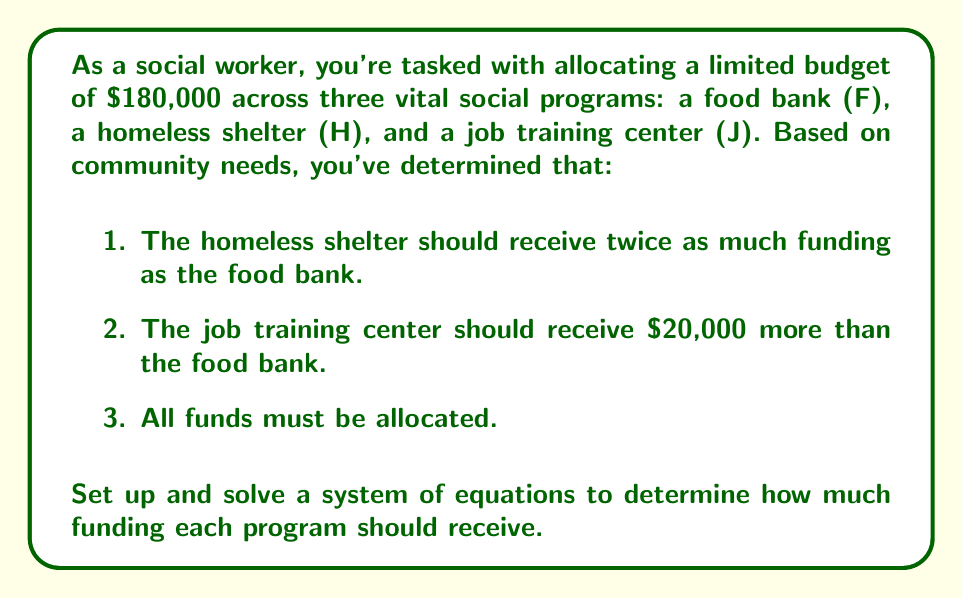Provide a solution to this math problem. Let's approach this problem step-by-step using a system of equations:

1. Define variables:
   Let $F$ = funding for the food bank
   Let $H$ = funding for the homeless shelter
   Let $J$ = funding for the job training center

2. Set up equations based on the given information:
   Equation 1: $H = 2F$ (homeless shelter receives twice as much as the food bank)
   Equation 2: $J = F + 20000$ (job training center receives $20,000 more than the food bank)
   Equation 3: $F + H + J = 180000$ (total budget allocation)

3. Substitute equations 1 and 2 into equation 3:
   $F + 2F + (F + 20000) = 180000$

4. Simplify:
   $4F + 20000 = 180000$

5. Solve for $F$:
   $4F = 160000$
   $F = 40000$

6. Calculate $H$ and $J$ using equations 1 and 2:
   $H = 2F = 2(40000) = 80000$
   $J = F + 20000 = 40000 + 20000 = 60000$

7. Verify the solution:
   $F + H + J = 40000 + 80000 + 60000 = 180000$

Therefore, the food bank should receive $40,000, the homeless shelter $80,000, and the job training center $60,000.
Answer: Food Bank: $40,000
Homeless Shelter: $80,000
Job Training Center: $60,000 